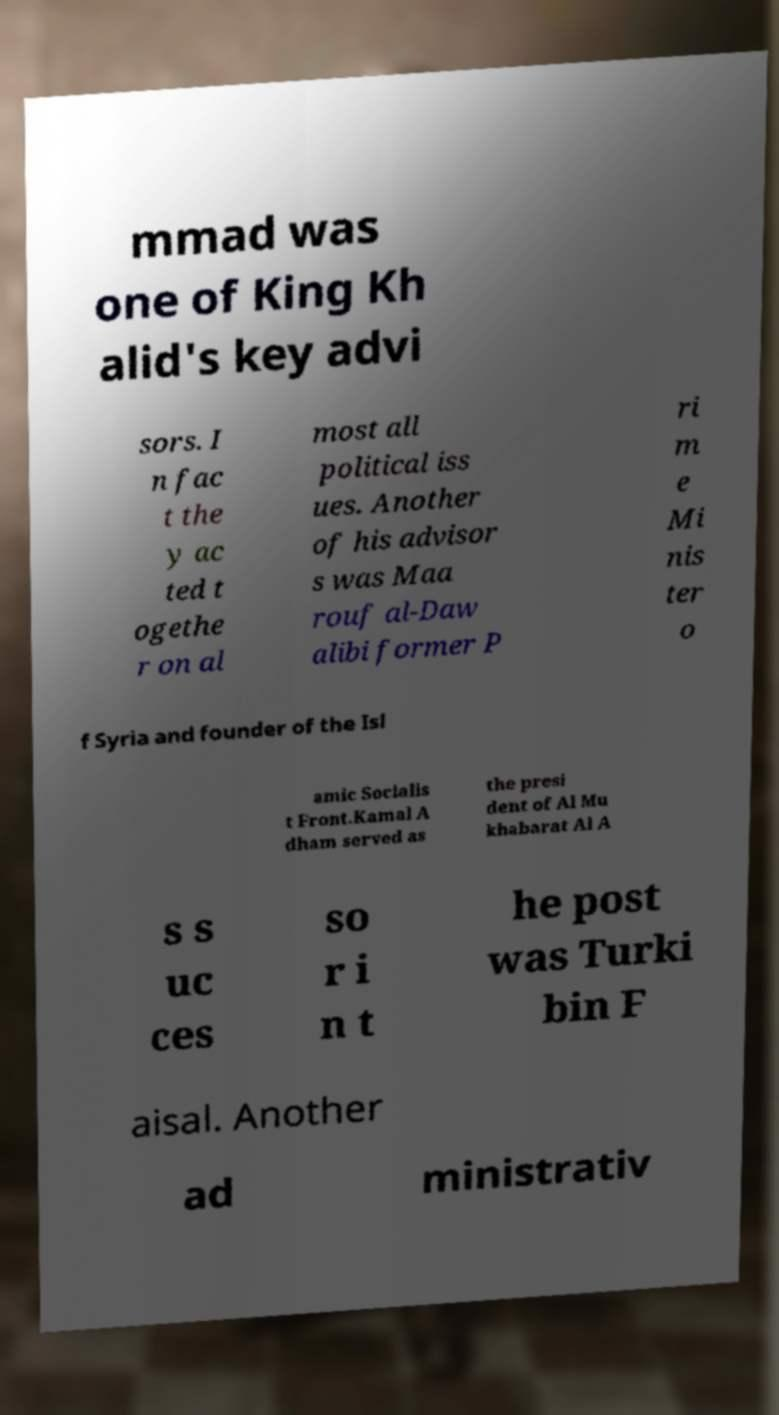Please read and relay the text visible in this image. What does it say? mmad was one of King Kh alid's key advi sors. I n fac t the y ac ted t ogethe r on al most all political iss ues. Another of his advisor s was Maa rouf al-Daw alibi former P ri m e Mi nis ter o f Syria and founder of the Isl amic Socialis t Front.Kamal A dham served as the presi dent of Al Mu khabarat Al A s s uc ces so r i n t he post was Turki bin F aisal. Another ad ministrativ 